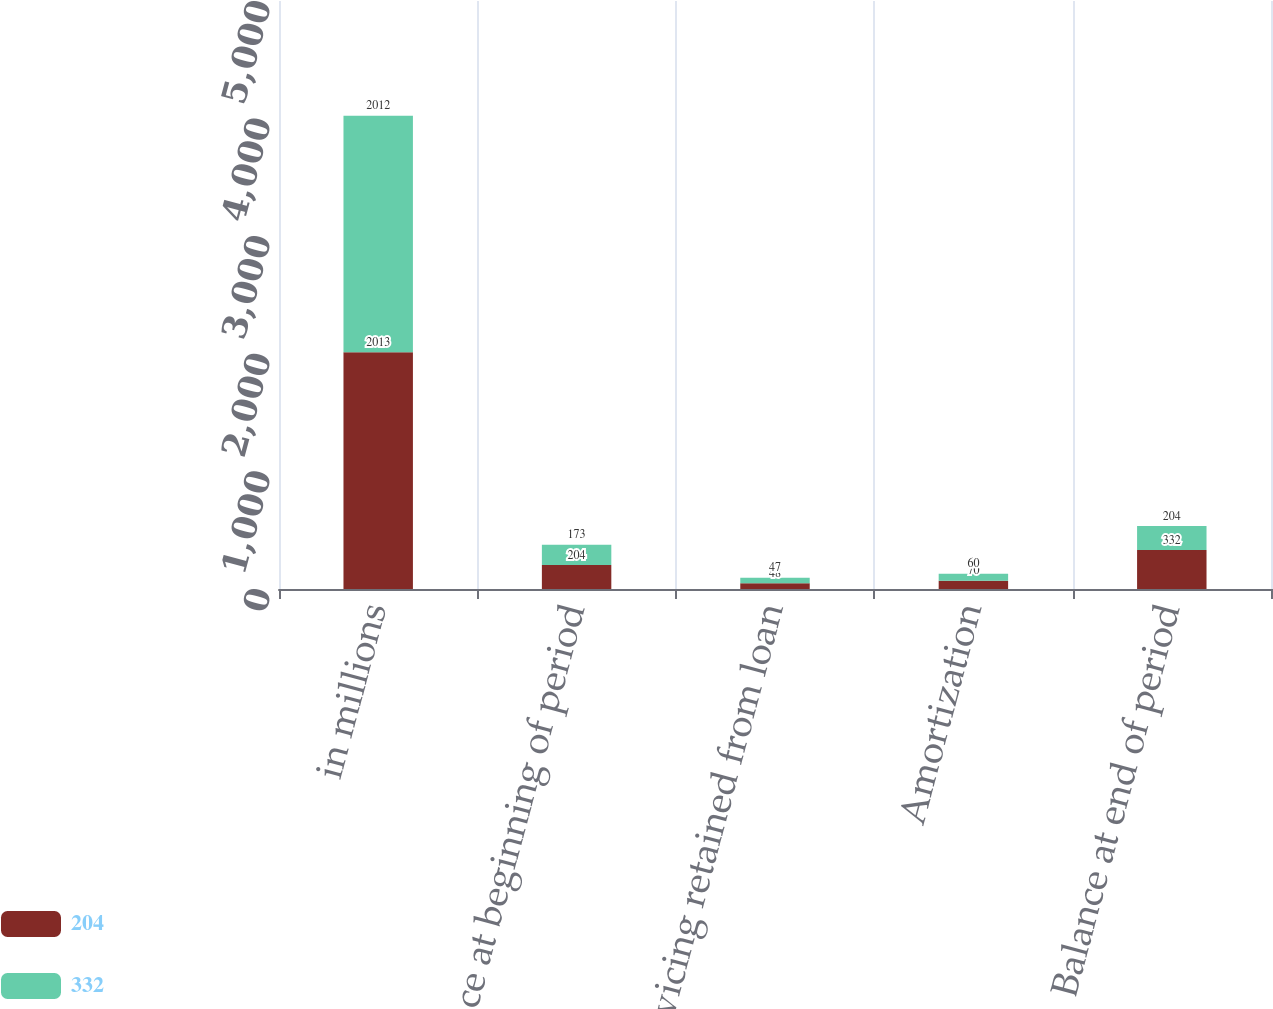<chart> <loc_0><loc_0><loc_500><loc_500><stacked_bar_chart><ecel><fcel>in millions<fcel>Balance at beginning of period<fcel>Servicing retained from loan<fcel>Amortization<fcel>Balance at end of period<nl><fcel>204<fcel>2013<fcel>204<fcel>48<fcel>70<fcel>332<nl><fcel>332<fcel>2012<fcel>173<fcel>47<fcel>60<fcel>204<nl></chart> 